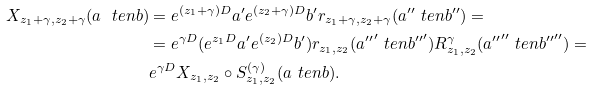Convert formula to latex. <formula><loc_0><loc_0><loc_500><loc_500>X _ { z _ { 1 } + \gamma , z _ { 2 } + \gamma } ( a \ t e n b ) & = e ^ { ( z _ { 1 } + \gamma ) D } a ^ { \prime } e ^ { ( z _ { 2 } + \gamma ) D } b ^ { \prime } r _ { z _ { 1 } + \gamma , z _ { 2 } + \gamma } ( a ^ { \prime \prime } \ t e n b ^ { \prime \prime } ) = \\ & = e ^ { \gamma D } ( e ^ { z _ { 1 } D } a ^ { \prime } e ^ { ( z _ { 2 } ) D } b ^ { \prime } ) r _ { z _ { 1 } , z _ { 2 } } ( { a ^ { \prime \prime } } ^ { \prime } \ t e n { b ^ { \prime \prime } } ^ { \prime } ) R ^ { \gamma } _ { z _ { 1 } , z _ { 2 } } ( { a ^ { \prime \prime } } ^ { \prime \prime } \ t e n { b ^ { \prime \prime } } ^ { \prime \prime } ) = \\ & e ^ { \gamma D } X _ { z _ { 1 } , z _ { 2 } } \circ S ^ { ( \gamma ) } _ { z _ { 1 } , z _ { 2 } } ( a \ t e n b ) .</formula> 